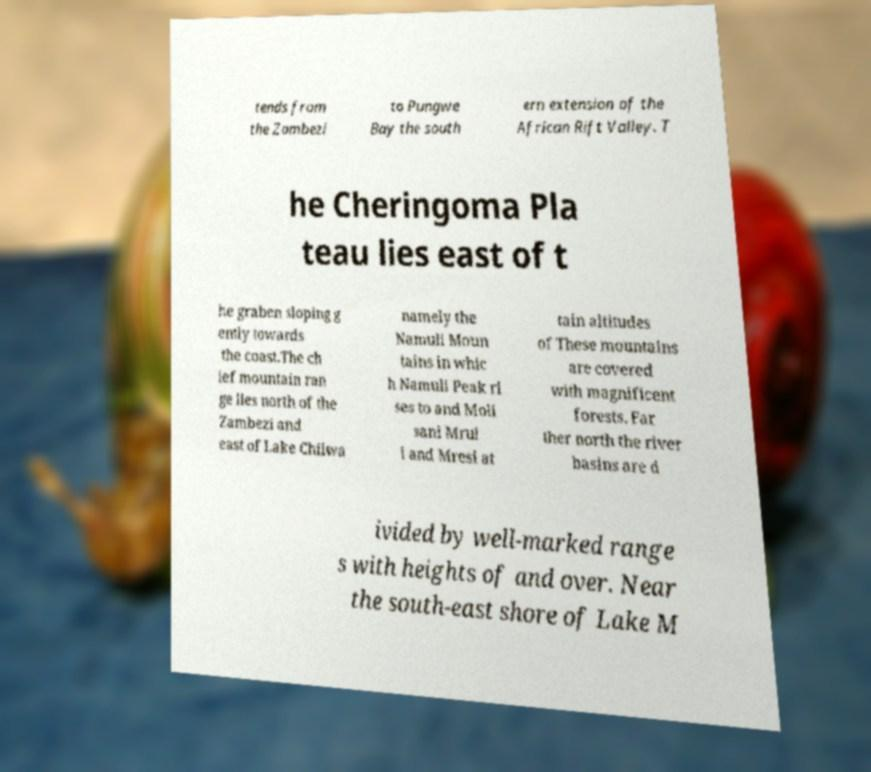I need the written content from this picture converted into text. Can you do that? tends from the Zambezi to Pungwe Bay the south ern extension of the African Rift Valley. T he Cheringoma Pla teau lies east of t he graben sloping g ently towards the coast.The ch ief mountain ran ge lies north of the Zambezi and east of Lake Chilwa namely the Namuli Moun tains in whic h Namuli Peak ri ses to and Moli sani Mrul i and Mresi at tain altitudes of These mountains are covered with magnificent forests. Far ther north the river basins are d ivided by well-marked range s with heights of and over. Near the south-east shore of Lake M 